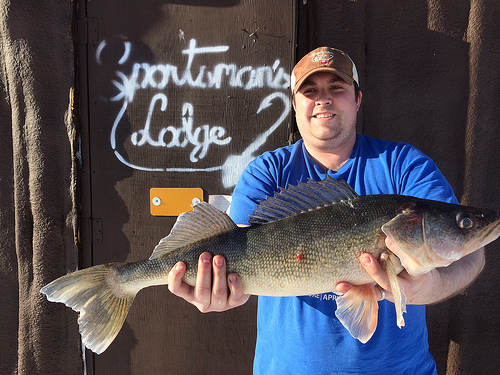<image>
Is there a tees behind the fish? Yes. From this viewpoint, the tees is positioned behind the fish, with the fish partially or fully occluding the tees. 